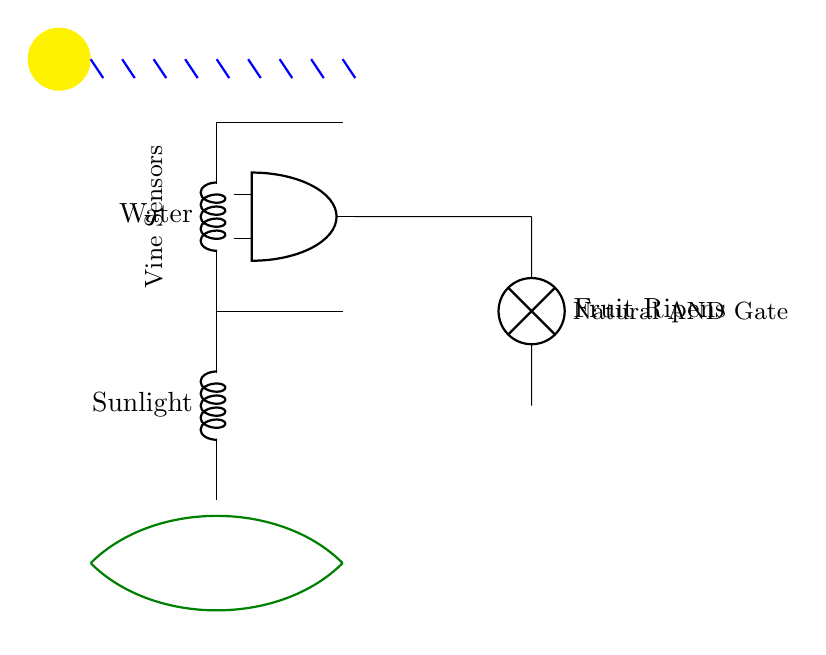What are the two inputs for the AND gate? The AND gate receives input from two sensors: one for Water and another for Sunlight.
Answer: Water, Sunlight What is the output of the circuit when both inputs are present? The output from the AND gate activates the lamp indicating that the Fruit Ripens when both Water and Sunlight are detected.
Answer: Fruit Ripens How is the Water sensor represented in the circuit? The Water sensor is represented by a cute inductor symbol appearing on the left side of the circuit diagram and labeled as Water.
Answer: Cute inductor What must be true for the output to be active? The output will only be active if both the Water and Sunlight inputs are present, as this is required for the AND operation to complete.
Answer: Both conditions must be met What type of circuit component is used to represent the AND gate? The AND gate is depicted using a specific node labeled as an AND port, which is a standard circuit component in logic designs.
Answer: AND port 